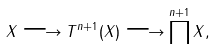<formula> <loc_0><loc_0><loc_500><loc_500>X \longrightarrow T ^ { n + 1 } ( X ) \longrightarrow \prod ^ { n + 1 } X ,</formula> 